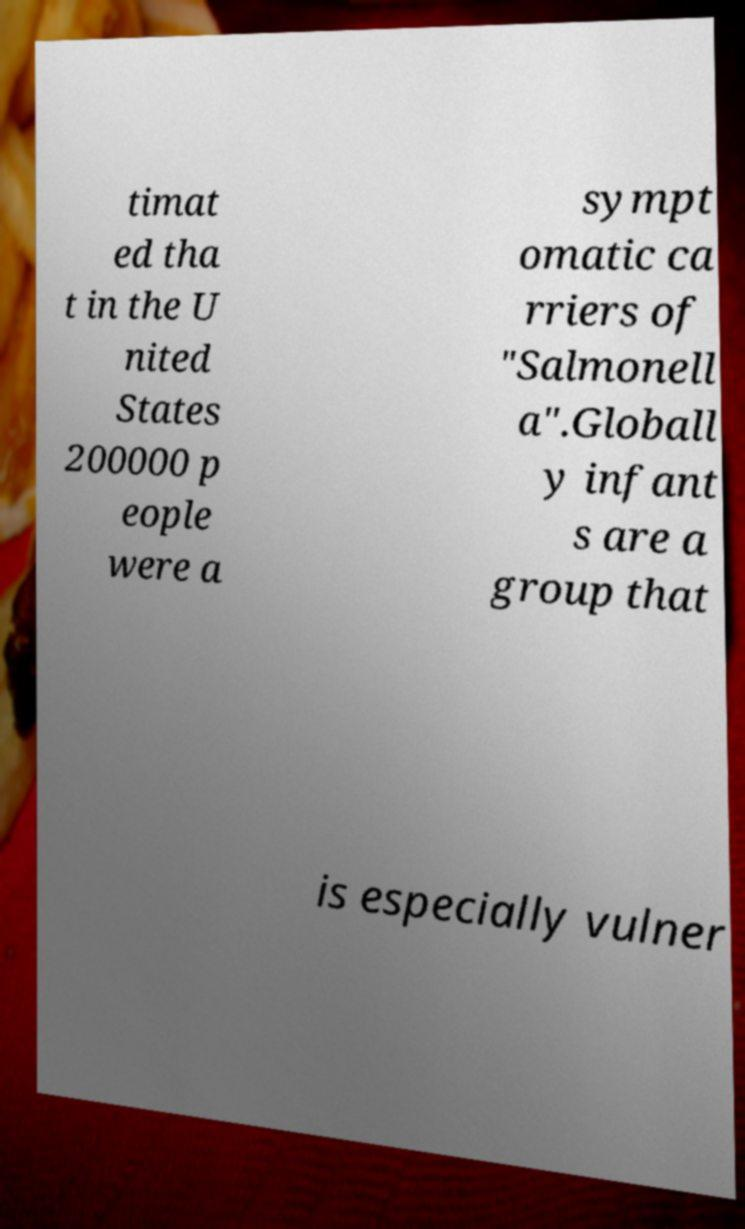Can you accurately transcribe the text from the provided image for me? timat ed tha t in the U nited States 200000 p eople were a sympt omatic ca rriers of "Salmonell a".Globall y infant s are a group that is especially vulner 